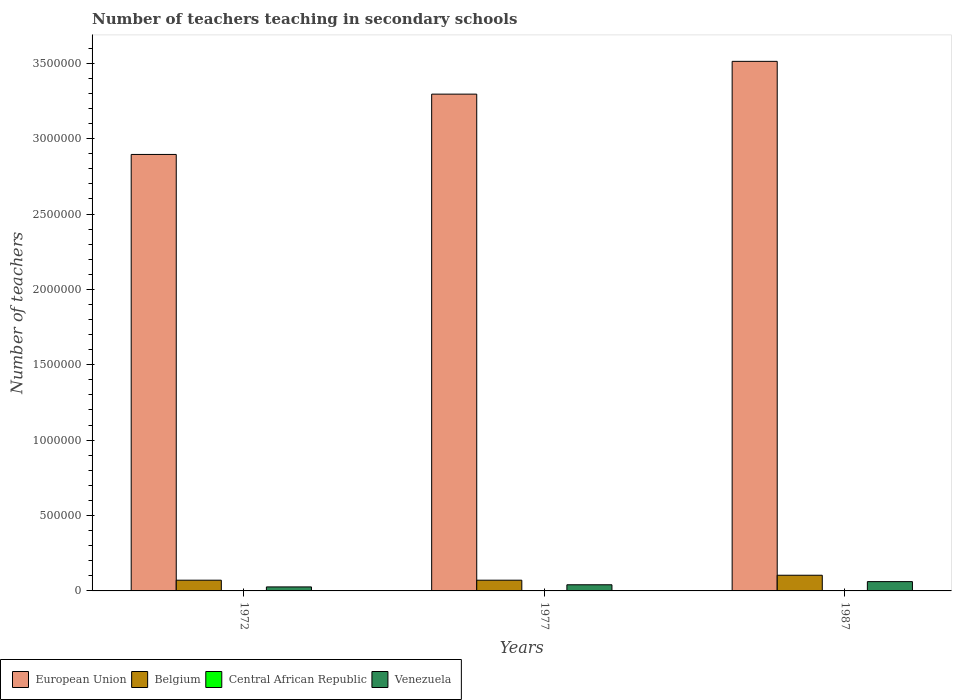How many different coloured bars are there?
Provide a succinct answer. 4. Are the number of bars per tick equal to the number of legend labels?
Provide a succinct answer. Yes. How many bars are there on the 3rd tick from the right?
Offer a very short reply. 4. What is the label of the 1st group of bars from the left?
Offer a terse response. 1972. In how many cases, is the number of bars for a given year not equal to the number of legend labels?
Make the answer very short. 0. What is the number of teachers teaching in secondary schools in European Union in 1977?
Offer a terse response. 3.30e+06. Across all years, what is the maximum number of teachers teaching in secondary schools in Venezuela?
Your answer should be compact. 6.17e+04. Across all years, what is the minimum number of teachers teaching in secondary schools in Central African Republic?
Make the answer very short. 533. What is the total number of teachers teaching in secondary schools in Venezuela in the graph?
Keep it short and to the point. 1.29e+05. What is the difference between the number of teachers teaching in secondary schools in Central African Republic in 1972 and that in 1987?
Offer a very short reply. -390. What is the difference between the number of teachers teaching in secondary schools in Venezuela in 1987 and the number of teachers teaching in secondary schools in Central African Republic in 1972?
Give a very brief answer. 6.11e+04. What is the average number of teachers teaching in secondary schools in European Union per year?
Your answer should be compact. 3.23e+06. In the year 1977, what is the difference between the number of teachers teaching in secondary schools in Central African Republic and number of teachers teaching in secondary schools in Venezuela?
Make the answer very short. -4.01e+04. In how many years, is the number of teachers teaching in secondary schools in European Union greater than 500000?
Offer a terse response. 3. What is the ratio of the number of teachers teaching in secondary schools in Belgium in 1972 to that in 1977?
Make the answer very short. 1. What is the difference between the highest and the second highest number of teachers teaching in secondary schools in Belgium?
Offer a terse response. 3.28e+04. What is the difference between the highest and the lowest number of teachers teaching in secondary schools in Central African Republic?
Give a very brief answer. 390. In how many years, is the number of teachers teaching in secondary schools in European Union greater than the average number of teachers teaching in secondary schools in European Union taken over all years?
Offer a very short reply. 2. What does the 4th bar from the left in 1977 represents?
Provide a succinct answer. Venezuela. What does the 1st bar from the right in 1972 represents?
Give a very brief answer. Venezuela. Is it the case that in every year, the sum of the number of teachers teaching in secondary schools in Belgium and number of teachers teaching in secondary schools in Central African Republic is greater than the number of teachers teaching in secondary schools in Venezuela?
Your answer should be very brief. Yes. Are all the bars in the graph horizontal?
Ensure brevity in your answer.  No. How many years are there in the graph?
Offer a terse response. 3. How are the legend labels stacked?
Give a very brief answer. Horizontal. What is the title of the graph?
Offer a terse response. Number of teachers teaching in secondary schools. What is the label or title of the X-axis?
Provide a succinct answer. Years. What is the label or title of the Y-axis?
Offer a very short reply. Number of teachers. What is the Number of teachers of European Union in 1972?
Give a very brief answer. 2.90e+06. What is the Number of teachers of Belgium in 1972?
Provide a short and direct response. 7.11e+04. What is the Number of teachers in Central African Republic in 1972?
Offer a very short reply. 533. What is the Number of teachers in Venezuela in 1972?
Your answer should be compact. 2.66e+04. What is the Number of teachers of European Union in 1977?
Make the answer very short. 3.30e+06. What is the Number of teachers of Belgium in 1977?
Offer a very short reply. 7.12e+04. What is the Number of teachers in Central African Republic in 1977?
Ensure brevity in your answer.  703. What is the Number of teachers in Venezuela in 1977?
Provide a short and direct response. 4.08e+04. What is the Number of teachers of European Union in 1987?
Ensure brevity in your answer.  3.51e+06. What is the Number of teachers in Belgium in 1987?
Offer a very short reply. 1.04e+05. What is the Number of teachers in Central African Republic in 1987?
Provide a short and direct response. 923. What is the Number of teachers of Venezuela in 1987?
Offer a very short reply. 6.17e+04. Across all years, what is the maximum Number of teachers of European Union?
Offer a terse response. 3.51e+06. Across all years, what is the maximum Number of teachers in Belgium?
Give a very brief answer. 1.04e+05. Across all years, what is the maximum Number of teachers of Central African Republic?
Ensure brevity in your answer.  923. Across all years, what is the maximum Number of teachers of Venezuela?
Make the answer very short. 6.17e+04. Across all years, what is the minimum Number of teachers in European Union?
Offer a very short reply. 2.90e+06. Across all years, what is the minimum Number of teachers in Belgium?
Give a very brief answer. 7.11e+04. Across all years, what is the minimum Number of teachers of Central African Republic?
Ensure brevity in your answer.  533. Across all years, what is the minimum Number of teachers of Venezuela?
Provide a short and direct response. 2.66e+04. What is the total Number of teachers in European Union in the graph?
Provide a succinct answer. 9.70e+06. What is the total Number of teachers in Belgium in the graph?
Your response must be concise. 2.46e+05. What is the total Number of teachers in Central African Republic in the graph?
Provide a succinct answer. 2159. What is the total Number of teachers in Venezuela in the graph?
Your response must be concise. 1.29e+05. What is the difference between the Number of teachers of European Union in 1972 and that in 1977?
Give a very brief answer. -4.00e+05. What is the difference between the Number of teachers in Belgium in 1972 and that in 1977?
Give a very brief answer. -58. What is the difference between the Number of teachers in Central African Republic in 1972 and that in 1977?
Give a very brief answer. -170. What is the difference between the Number of teachers of Venezuela in 1972 and that in 1977?
Your response must be concise. -1.42e+04. What is the difference between the Number of teachers of European Union in 1972 and that in 1987?
Provide a short and direct response. -6.17e+05. What is the difference between the Number of teachers in Belgium in 1972 and that in 1987?
Give a very brief answer. -3.29e+04. What is the difference between the Number of teachers in Central African Republic in 1972 and that in 1987?
Offer a terse response. -390. What is the difference between the Number of teachers in Venezuela in 1972 and that in 1987?
Your response must be concise. -3.51e+04. What is the difference between the Number of teachers of European Union in 1977 and that in 1987?
Give a very brief answer. -2.17e+05. What is the difference between the Number of teachers in Belgium in 1977 and that in 1987?
Keep it short and to the point. -3.28e+04. What is the difference between the Number of teachers in Central African Republic in 1977 and that in 1987?
Your answer should be very brief. -220. What is the difference between the Number of teachers of Venezuela in 1977 and that in 1987?
Provide a succinct answer. -2.09e+04. What is the difference between the Number of teachers in European Union in 1972 and the Number of teachers in Belgium in 1977?
Your answer should be very brief. 2.82e+06. What is the difference between the Number of teachers in European Union in 1972 and the Number of teachers in Central African Republic in 1977?
Your response must be concise. 2.89e+06. What is the difference between the Number of teachers in European Union in 1972 and the Number of teachers in Venezuela in 1977?
Your response must be concise. 2.85e+06. What is the difference between the Number of teachers of Belgium in 1972 and the Number of teachers of Central African Republic in 1977?
Make the answer very short. 7.04e+04. What is the difference between the Number of teachers in Belgium in 1972 and the Number of teachers in Venezuela in 1977?
Provide a short and direct response. 3.03e+04. What is the difference between the Number of teachers of Central African Republic in 1972 and the Number of teachers of Venezuela in 1977?
Offer a terse response. -4.03e+04. What is the difference between the Number of teachers in European Union in 1972 and the Number of teachers in Belgium in 1987?
Offer a terse response. 2.79e+06. What is the difference between the Number of teachers in European Union in 1972 and the Number of teachers in Central African Republic in 1987?
Ensure brevity in your answer.  2.89e+06. What is the difference between the Number of teachers of European Union in 1972 and the Number of teachers of Venezuela in 1987?
Keep it short and to the point. 2.83e+06. What is the difference between the Number of teachers in Belgium in 1972 and the Number of teachers in Central African Republic in 1987?
Your response must be concise. 7.02e+04. What is the difference between the Number of teachers in Belgium in 1972 and the Number of teachers in Venezuela in 1987?
Your answer should be compact. 9441. What is the difference between the Number of teachers of Central African Republic in 1972 and the Number of teachers of Venezuela in 1987?
Make the answer very short. -6.11e+04. What is the difference between the Number of teachers in European Union in 1977 and the Number of teachers in Belgium in 1987?
Keep it short and to the point. 3.19e+06. What is the difference between the Number of teachers of European Union in 1977 and the Number of teachers of Central African Republic in 1987?
Keep it short and to the point. 3.29e+06. What is the difference between the Number of teachers of European Union in 1977 and the Number of teachers of Venezuela in 1987?
Your response must be concise. 3.23e+06. What is the difference between the Number of teachers in Belgium in 1977 and the Number of teachers in Central African Republic in 1987?
Offer a terse response. 7.02e+04. What is the difference between the Number of teachers in Belgium in 1977 and the Number of teachers in Venezuela in 1987?
Make the answer very short. 9499. What is the difference between the Number of teachers in Central African Republic in 1977 and the Number of teachers in Venezuela in 1987?
Keep it short and to the point. -6.10e+04. What is the average Number of teachers in European Union per year?
Your answer should be very brief. 3.23e+06. What is the average Number of teachers of Belgium per year?
Provide a succinct answer. 8.21e+04. What is the average Number of teachers in Central African Republic per year?
Your response must be concise. 719.67. What is the average Number of teachers in Venezuela per year?
Make the answer very short. 4.30e+04. In the year 1972, what is the difference between the Number of teachers in European Union and Number of teachers in Belgium?
Your answer should be compact. 2.82e+06. In the year 1972, what is the difference between the Number of teachers of European Union and Number of teachers of Central African Republic?
Provide a succinct answer. 2.89e+06. In the year 1972, what is the difference between the Number of teachers of European Union and Number of teachers of Venezuela?
Make the answer very short. 2.87e+06. In the year 1972, what is the difference between the Number of teachers in Belgium and Number of teachers in Central African Republic?
Provide a short and direct response. 7.06e+04. In the year 1972, what is the difference between the Number of teachers of Belgium and Number of teachers of Venezuela?
Ensure brevity in your answer.  4.46e+04. In the year 1972, what is the difference between the Number of teachers in Central African Republic and Number of teachers in Venezuela?
Provide a succinct answer. -2.60e+04. In the year 1977, what is the difference between the Number of teachers of European Union and Number of teachers of Belgium?
Your answer should be very brief. 3.22e+06. In the year 1977, what is the difference between the Number of teachers of European Union and Number of teachers of Central African Republic?
Provide a succinct answer. 3.29e+06. In the year 1977, what is the difference between the Number of teachers in European Union and Number of teachers in Venezuela?
Your response must be concise. 3.25e+06. In the year 1977, what is the difference between the Number of teachers in Belgium and Number of teachers in Central African Republic?
Offer a very short reply. 7.05e+04. In the year 1977, what is the difference between the Number of teachers of Belgium and Number of teachers of Venezuela?
Give a very brief answer. 3.04e+04. In the year 1977, what is the difference between the Number of teachers of Central African Republic and Number of teachers of Venezuela?
Your answer should be very brief. -4.01e+04. In the year 1987, what is the difference between the Number of teachers in European Union and Number of teachers in Belgium?
Your answer should be very brief. 3.41e+06. In the year 1987, what is the difference between the Number of teachers in European Union and Number of teachers in Central African Republic?
Offer a very short reply. 3.51e+06. In the year 1987, what is the difference between the Number of teachers of European Union and Number of teachers of Venezuela?
Ensure brevity in your answer.  3.45e+06. In the year 1987, what is the difference between the Number of teachers in Belgium and Number of teachers in Central African Republic?
Offer a terse response. 1.03e+05. In the year 1987, what is the difference between the Number of teachers of Belgium and Number of teachers of Venezuela?
Make the answer very short. 4.23e+04. In the year 1987, what is the difference between the Number of teachers in Central African Republic and Number of teachers in Venezuela?
Make the answer very short. -6.07e+04. What is the ratio of the Number of teachers of European Union in 1972 to that in 1977?
Your answer should be compact. 0.88. What is the ratio of the Number of teachers in Belgium in 1972 to that in 1977?
Your answer should be very brief. 1. What is the ratio of the Number of teachers in Central African Republic in 1972 to that in 1977?
Make the answer very short. 0.76. What is the ratio of the Number of teachers of Venezuela in 1972 to that in 1977?
Provide a short and direct response. 0.65. What is the ratio of the Number of teachers in European Union in 1972 to that in 1987?
Give a very brief answer. 0.82. What is the ratio of the Number of teachers of Belgium in 1972 to that in 1987?
Provide a short and direct response. 0.68. What is the ratio of the Number of teachers in Central African Republic in 1972 to that in 1987?
Keep it short and to the point. 0.58. What is the ratio of the Number of teachers in Venezuela in 1972 to that in 1987?
Provide a succinct answer. 0.43. What is the ratio of the Number of teachers in European Union in 1977 to that in 1987?
Your response must be concise. 0.94. What is the ratio of the Number of teachers of Belgium in 1977 to that in 1987?
Provide a succinct answer. 0.68. What is the ratio of the Number of teachers of Central African Republic in 1977 to that in 1987?
Ensure brevity in your answer.  0.76. What is the ratio of the Number of teachers in Venezuela in 1977 to that in 1987?
Offer a very short reply. 0.66. What is the difference between the highest and the second highest Number of teachers in European Union?
Give a very brief answer. 2.17e+05. What is the difference between the highest and the second highest Number of teachers in Belgium?
Give a very brief answer. 3.28e+04. What is the difference between the highest and the second highest Number of teachers in Central African Republic?
Your answer should be very brief. 220. What is the difference between the highest and the second highest Number of teachers of Venezuela?
Your answer should be compact. 2.09e+04. What is the difference between the highest and the lowest Number of teachers in European Union?
Offer a very short reply. 6.17e+05. What is the difference between the highest and the lowest Number of teachers in Belgium?
Your answer should be compact. 3.29e+04. What is the difference between the highest and the lowest Number of teachers in Central African Republic?
Offer a very short reply. 390. What is the difference between the highest and the lowest Number of teachers in Venezuela?
Make the answer very short. 3.51e+04. 